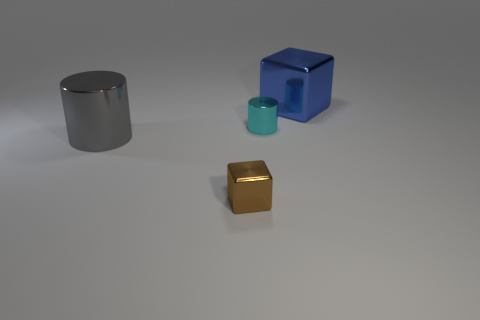Is the block that is to the left of the blue object made of the same material as the big object in front of the large metallic cube? Yes, both the block to the left of the blue object and the big object in front of the large metallic cube appear to have a similar reflective surface, which suggests that they could be made of the same or similar types of materials, likely a type of metal. 